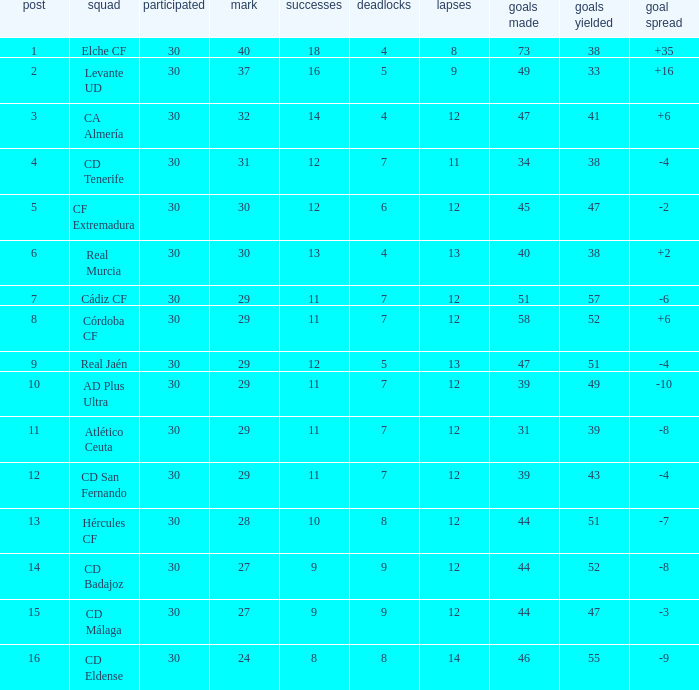What is the lowest amount of draws with less than 12 wins and less than 30 played? None. 